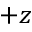<formula> <loc_0><loc_0><loc_500><loc_500>+ z</formula> 